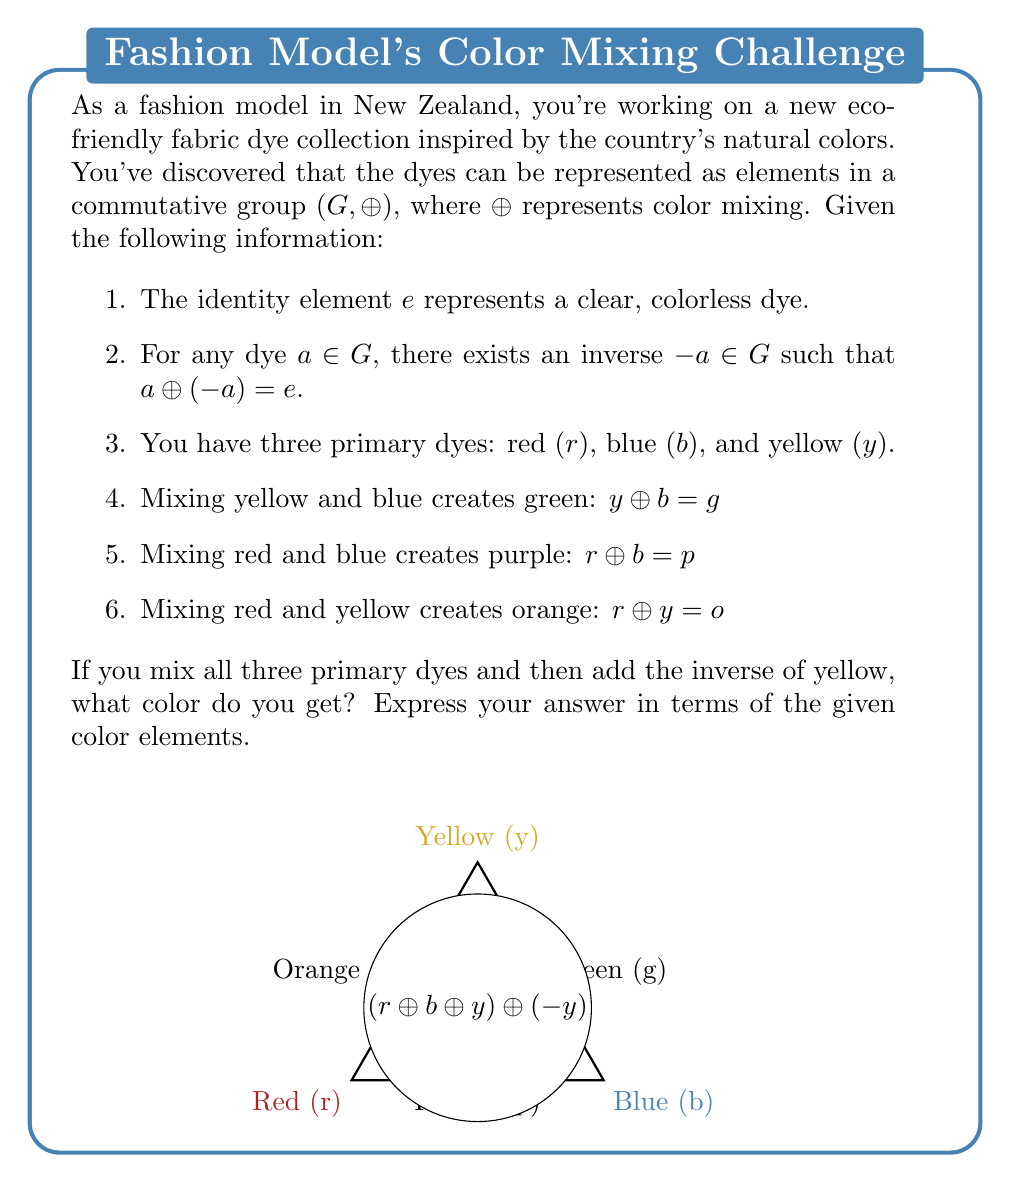Show me your answer to this math problem. Let's approach this step-by-step:

1) First, we mix all three primary dyes:
   $r \oplus b \oplus y$

2) Then we add the inverse of yellow:
   $(r \oplus b \oplus y) \oplus (-y)$

3) Using the associative property of groups, we can rearrange this:
   $r \oplus b \oplus (y \oplus (-y))$

4) We know that for any element $a$ in a group, $a \oplus (-a) = e$ (the identity element). So:
   $y \oplus (-y) = e$

5) Substituting this back into our expression:
   $r \oplus b \oplus e$

6) The identity element $e$ doesn't change the result when added to any other element, so:
   $r \oplus b$

7) We're given that $r \oplus b = p$ (purple)

Therefore, $(r \oplus b \oplus y) \oplus (-y) = r \oplus b = p$
Answer: $p$ (purple) 